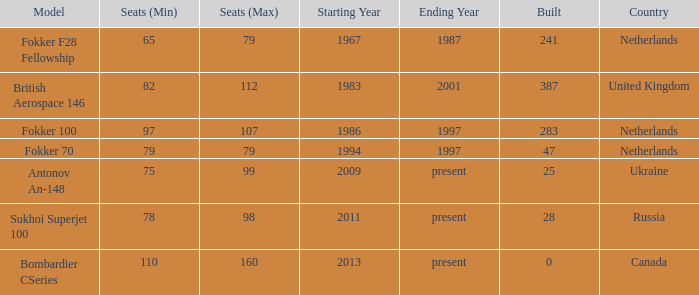In which years were there 241 fokker 70 model cabins manufactured? 1994-1997. 